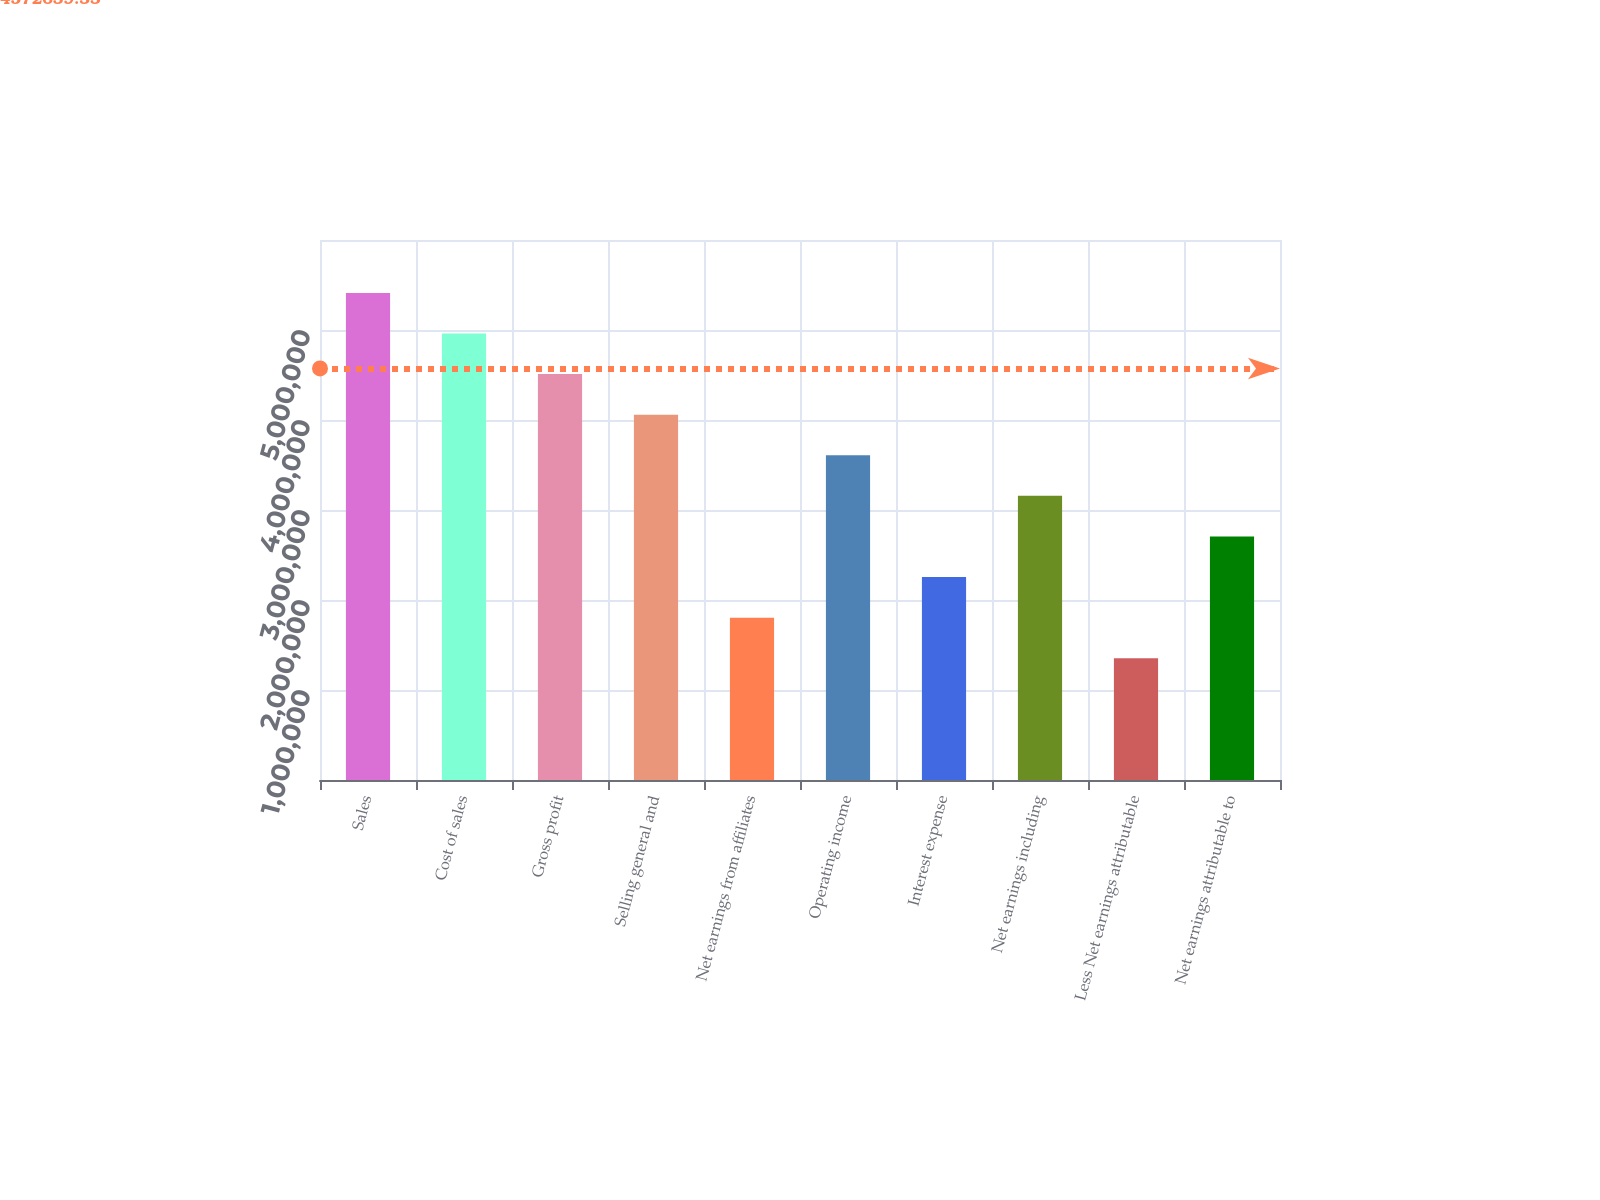Convert chart. <chart><loc_0><loc_0><loc_500><loc_500><bar_chart><fcel>Sales<fcel>Cost of sales<fcel>Gross profit<fcel>Selling general and<fcel>Net earnings from affiliates<fcel>Operating income<fcel>Interest expense<fcel>Net earnings including<fcel>Less Net earnings attributable<fcel>Net earnings attributable to<nl><fcel>5.41224e+06<fcel>4.96122e+06<fcel>4.5102e+06<fcel>4.05918e+06<fcel>1.80408e+06<fcel>3.60816e+06<fcel>2.2551e+06<fcel>3.15714e+06<fcel>1.35306e+06<fcel>2.70612e+06<nl></chart> 